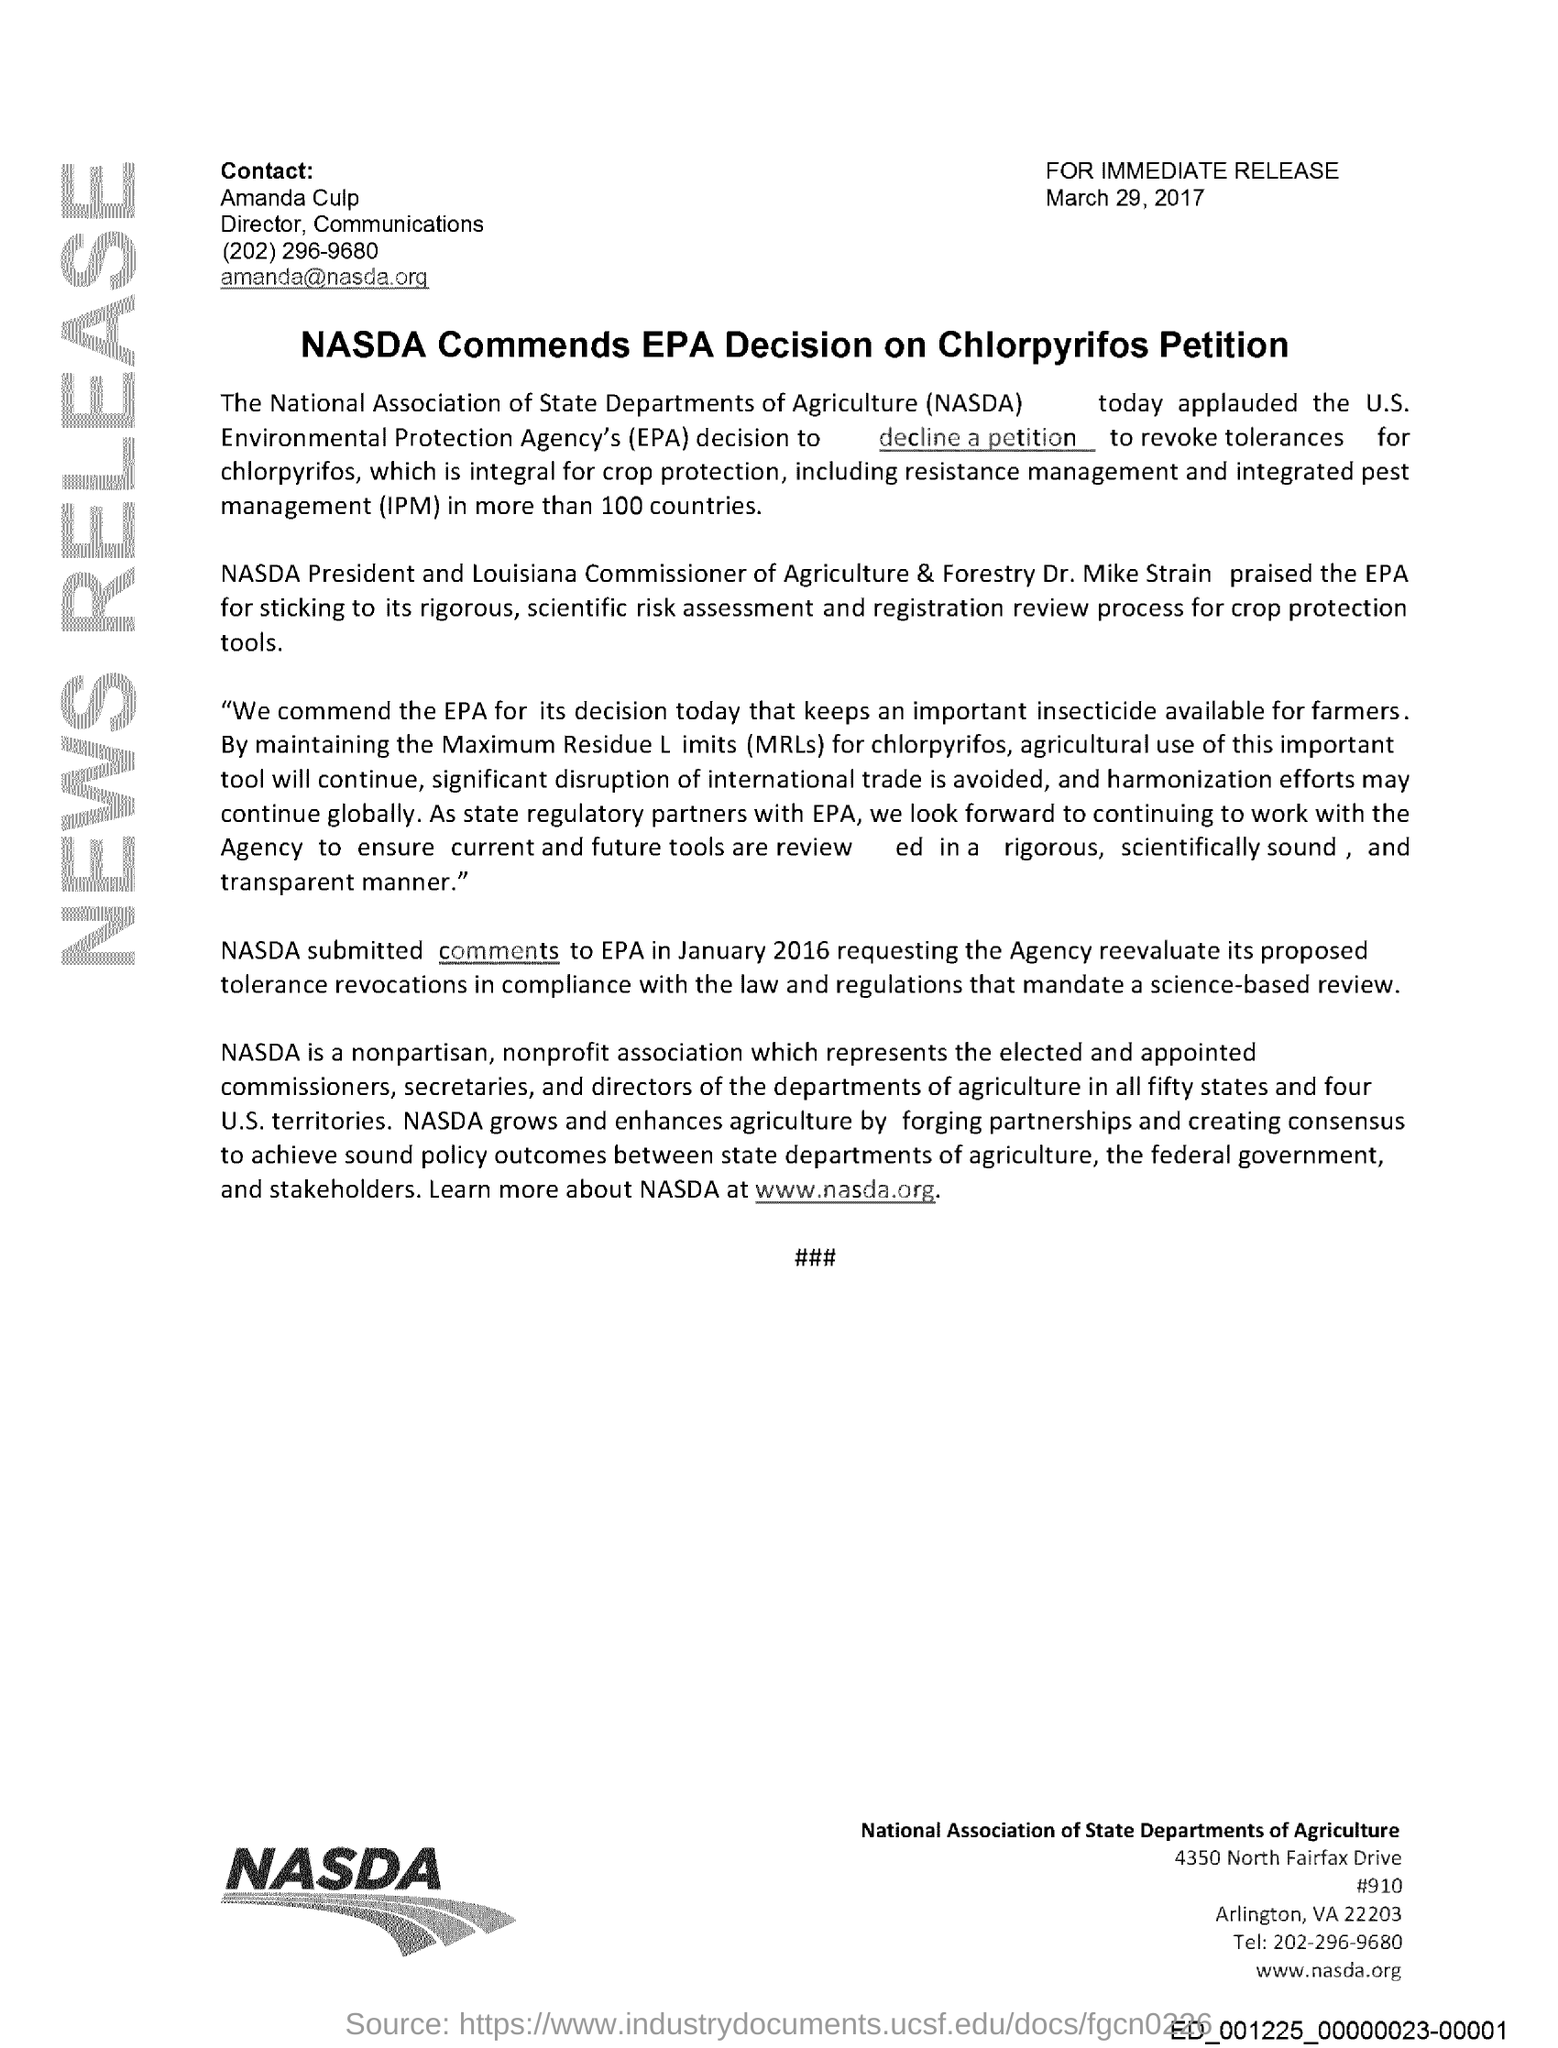Highlight a few significant elements in this photo. The full form of NASDA is the National Association of State Departments of Agriculture. The issued date of this document is March 29, 2017. On January 2016, NASDA submitted its comments to the EPA. The Louisiana Commissioner of Agriculture & Forestry is Dr. Mike Strain. 